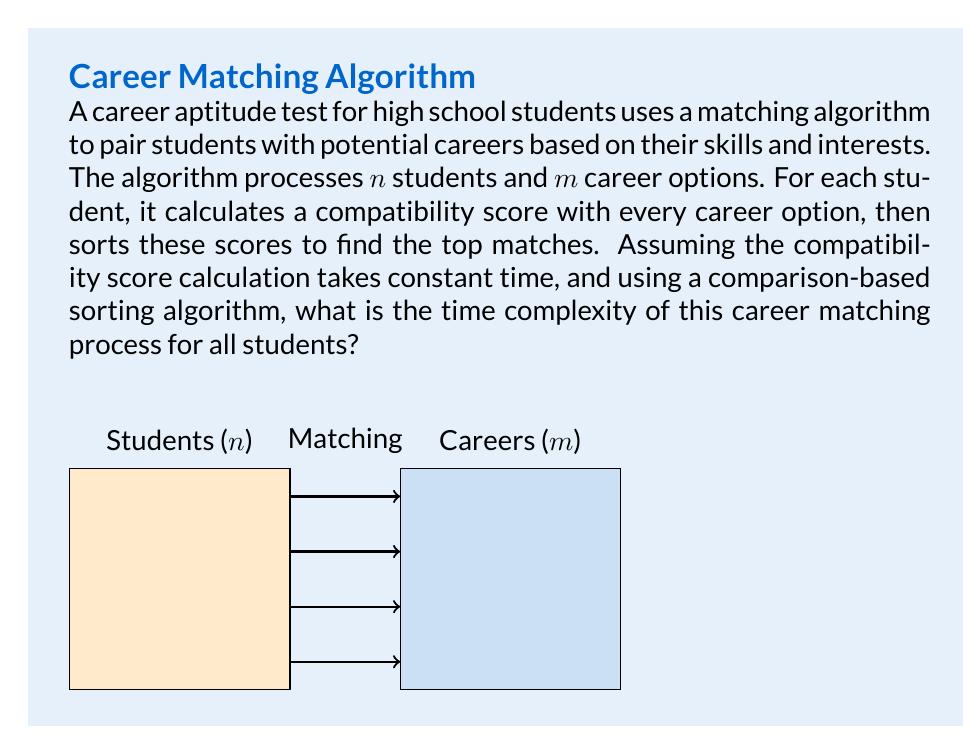Teach me how to tackle this problem. Let's break down the algorithm and analyze its time complexity step by step:

1) For each student, the algorithm performs two main operations:
   a) Calculating compatibility scores
   b) Sorting these scores

2) Calculating compatibility scores:
   - For each student, we calculate a score for each career option
   - This takes $O(m)$ time for one student
   - For $n$ students, this step takes $O(nm)$ time

3) Sorting the scores:
   - For each student, we need to sort $m$ scores
   - Using a comparison-based sorting algorithm (e.g., quicksort or mergesort), this takes $O(m \log m)$ time for one student
   - For $n$ students, this step takes $O(nm \log m)$ time

4) The total time complexity is the sum of these two steps:
   $O(nm) + O(nm \log m) = O(nm \log m)$

   This is because $O(nm \log m)$ dominates $O(nm)$ as $m$ increases.

5) Therefore, the overall time complexity for matching all students to careers is $O(nm \log m)$.

This analysis assumes that the number of career options $(m)$ is significantly large. If $m$ were very small and constant, the time complexity would reduce to $O(n)$, but in a realistic scenario for a comprehensive career aptitude test, $m$ would be large enough to make the $\log m$ factor significant.
Answer: $O(nm \log m)$ 